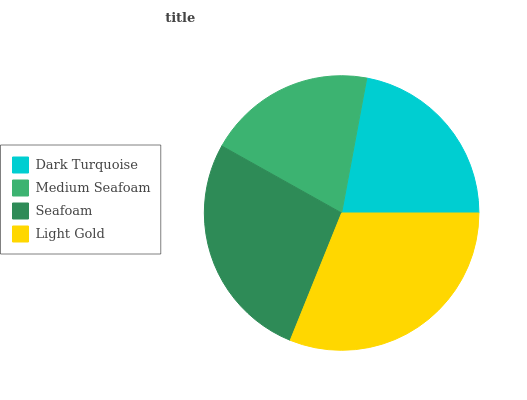Is Medium Seafoam the minimum?
Answer yes or no. Yes. Is Light Gold the maximum?
Answer yes or no. Yes. Is Seafoam the minimum?
Answer yes or no. No. Is Seafoam the maximum?
Answer yes or no. No. Is Seafoam greater than Medium Seafoam?
Answer yes or no. Yes. Is Medium Seafoam less than Seafoam?
Answer yes or no. Yes. Is Medium Seafoam greater than Seafoam?
Answer yes or no. No. Is Seafoam less than Medium Seafoam?
Answer yes or no. No. Is Seafoam the high median?
Answer yes or no. Yes. Is Dark Turquoise the low median?
Answer yes or no. Yes. Is Medium Seafoam the high median?
Answer yes or no. No. Is Medium Seafoam the low median?
Answer yes or no. No. 